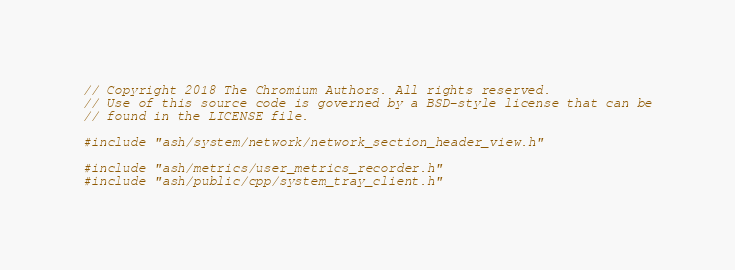<code> <loc_0><loc_0><loc_500><loc_500><_C++_>// Copyright 2018 The Chromium Authors. All rights reserved.
// Use of this source code is governed by a BSD-style license that can be
// found in the LICENSE file.

#include "ash/system/network/network_section_header_view.h"

#include "ash/metrics/user_metrics_recorder.h"
#include "ash/public/cpp/system_tray_client.h"</code> 